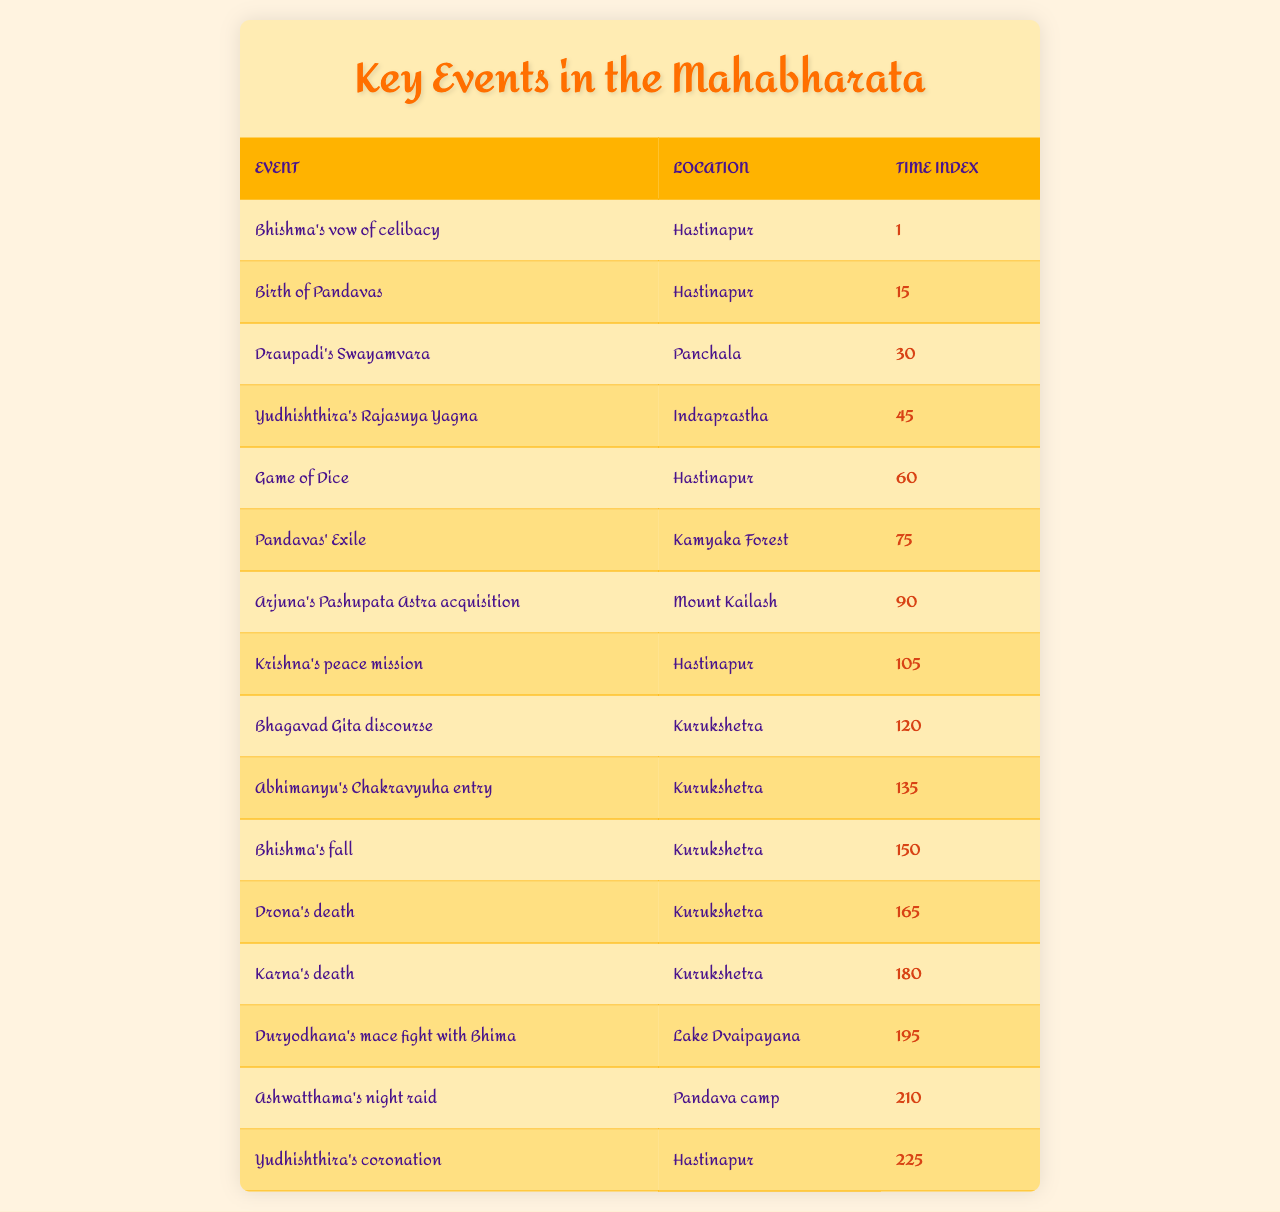What event took place at Hastinapur? By examining the table, we can find that "Bhishma's vow of celibacy," "Birth of Pandavas," "Game of Dice," and "Yudhishthira's coronation" all occurred at Hastinapur.
Answer: Bhishma's vow of celibacy, Birth of Pandavas, Game of Dice, Yudhishthira's coronation Where did Draupadi's Swayamvara happen? The table clearly indicates that Draupadi's Swayamvara took place in Panchala.
Answer: Panchala What is the time index for Arjuna's Pashupata Astra acquisition? Referring to the table, the time index for Arjuna's Pashupata Astra acquisition is 90.
Answer: 90 How many key events occurred in Kurukshetra? By counting the entries in the table, we see that there are five events listed with Kurukshetra as the location: "Bhagavad Gita discourse," "Abhimanyu's Chakravyuha entry," "Bhishma's fall," "Drona's death," and "Karna's death."
Answer: 5 Is Yudhishthira's Rajasuya Yagna before or after the Game of Dice? The time index for Yudhishthira's Rajasuya Yagna is 45, while the Game of Dice has a time index of 60. Because 45 is less than 60, it is before.
Answer: Before What is the average time index of events that took place in Kurukshetra? We take the time indices for the Kurukshetra events: 120 (Bhagavad Gita discourse), 135 (Abhimanyu's Chakravyuha entry), 150 (Bhishma's fall), 165 (Drona's death), and 180 (Karna's death). Summing these gives 750, and since there are 5 events, the average is 750 / 5 = 150.
Answer: 150 How many events took place after the Pandavas' Exile? The time index for Pandavas' Exile is 75. Looking at the table, the events after this include: "Arjuna's Pashupata Astra acquisition," "Krishna's peace mission," "Bhagavad Gita discourse," "Abhimanyu's Chakravyuha entry," "Bhishma's fall," "Drona's death," "Karna's death," "Duryodhana's mace fight with Bhima," "Ashwatthama's night raid," and "Yudhishthira's coronation," which totals 10 events.
Answer: 10 Did Duryodhana's mace fight with Bhima happen before or after Yudhishthira's coronation? The time index for Duryodhana's mace fight with Bhima is 195, and for Yudhishthira's coronation, it is 225. Since 195 is less than 225, it happened before.
Answer: Before Which event had the earliest time index? The earliest time index listed in the table is for "Bhishma's vow of celibacy," which is at time index 1.
Answer: Bhishma's vow of celibacy 